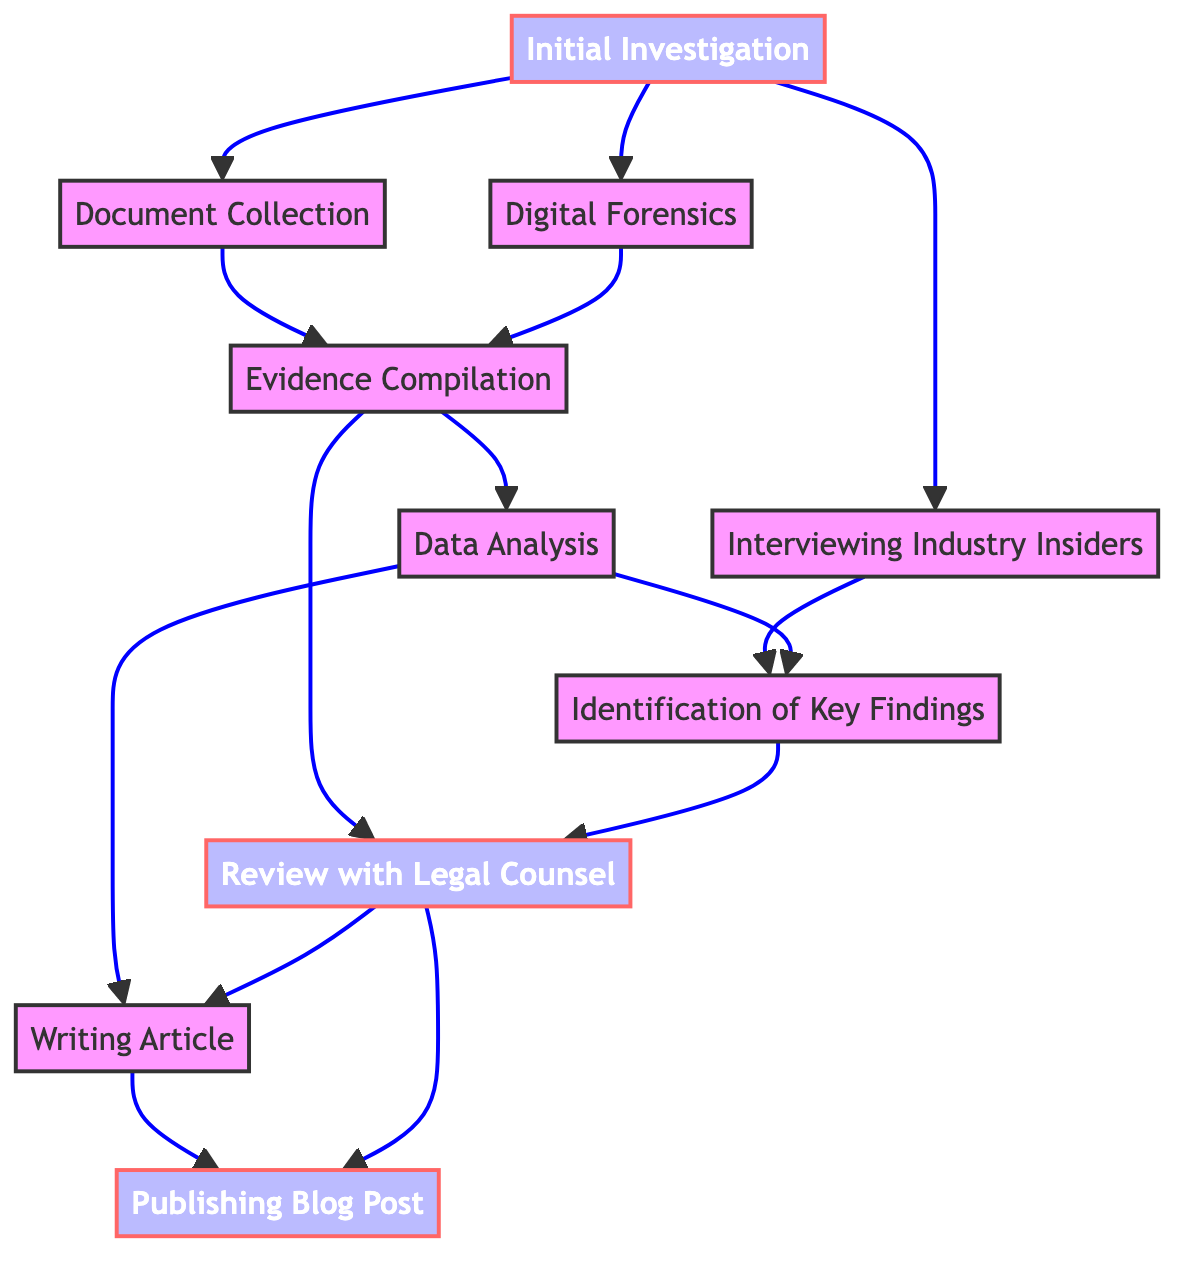What is the first step in the whistleblowing process? The first step in the whistleblowing process is "Initial Investigation," which involves conducting preliminary research and gathering initial evidence indicating corruption.
Answer: Initial Investigation How many steps are involved in the flow chart? The flow chart includes a total of ten distinct steps, ranging from "Initial Investigation" to "Publishing Blog Post."
Answer: 10 What are the dependencies for "Review with Legal Counsel"? The dependencies for "Review with Legal Counsel" are "Evidence Compilation" and "Identification of Key Findings," both of which must be completed before this step can occur.
Answer: Evidence Compilation, Identification of Key Findings Which step comes directly before "Publishing Blog Post"? The step that comes directly before "Publishing Blog Post" is "Review with Legal Counsel," signifying that the blog post is finalized after legal review.
Answer: Review with Legal Counsel What does "Data Analysis" depend on? "Data Analysis" depends on two steps: "Evidence Compilation" and "Interviewing Industry Insiders," indicating that both are necessary to conduct a thorough analysis of the evidence.
Answer: Evidence Compilation, Interviewing Industry Insiders How many steps flow into "Writing Article"? Two steps flow into "Writing Article," which are "Data Analysis" and "Review with Legal Counsel," meaning both must be completed before writing the article.
Answer: 2 What is the last step in the process? The last step in the process is "Publishing Blog Post," representing the culmination of all previous efforts to expose corruption in the gambling industry.
Answer: Publishing Blog Post List the two steps that follow "Identification of Key Findings." The two subsequent steps that follow "Identification of Key Findings" are "Review with Legal Counsel" and "Writing Article," indicating that once key findings are identified, they lead to legal review and article writing.
Answer: Review with Legal Counsel, Writing Article What role does "Digital Forensics" play in the process? "Digital Forensics" is essential for using digital tools to retrieve and verify the authenticity of electronic evidence, and it contributes to "Evidence Compilation."
Answer: Evidence Compilation 